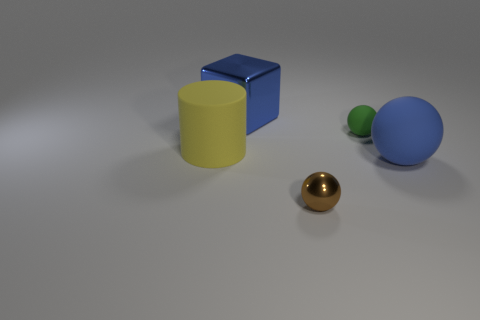Add 5 brown metallic spheres. How many objects exist? 10 Subtract all cubes. How many objects are left? 4 Add 3 blue metallic things. How many blue metallic things are left? 4 Add 3 blue matte things. How many blue matte things exist? 4 Subtract 0 cyan cylinders. How many objects are left? 5 Subtract all blue metal objects. Subtract all brown shiny spheres. How many objects are left? 3 